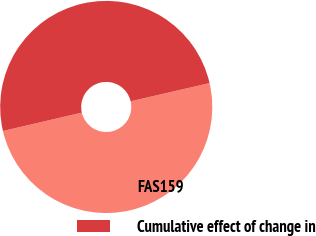Convert chart to OTSL. <chart><loc_0><loc_0><loc_500><loc_500><pie_chart><fcel>FAS159<fcel>Cumulative effect of change in<nl><fcel>49.98%<fcel>50.02%<nl></chart> 